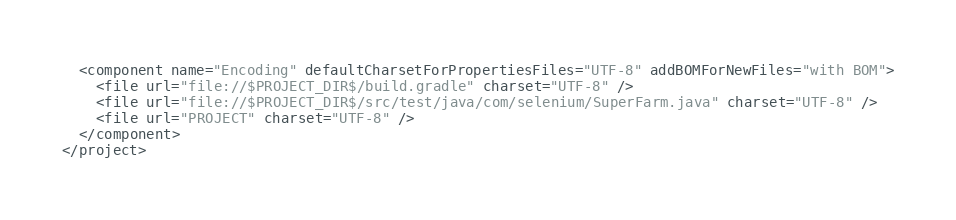Convert code to text. <code><loc_0><loc_0><loc_500><loc_500><_XML_>  <component name="Encoding" defaultCharsetForPropertiesFiles="UTF-8" addBOMForNewFiles="with BOM">
    <file url="file://$PROJECT_DIR$/build.gradle" charset="UTF-8" />
    <file url="file://$PROJECT_DIR$/src/test/java/com/selenium/SuperFarm.java" charset="UTF-8" />
    <file url="PROJECT" charset="UTF-8" />
  </component>
</project></code> 